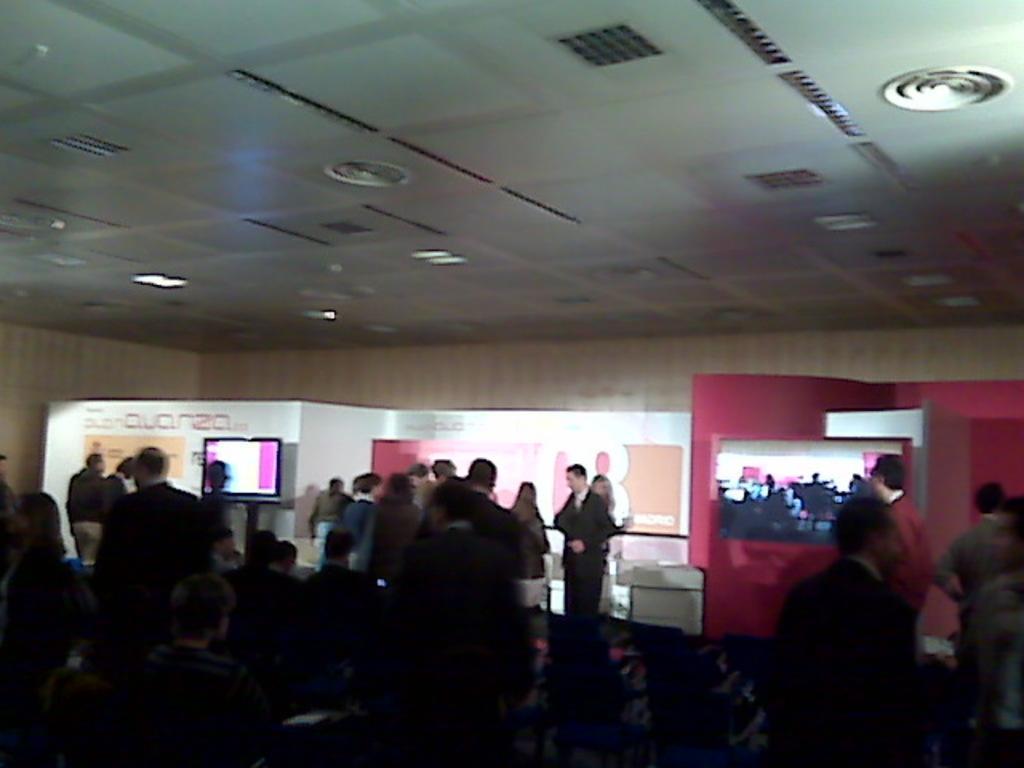Can you describe this image briefly? Here in this picture we can see group of people standing here and there on the floor over there and behind them we can see a banner present and we can also see a television present on a stand over there and on the roof we can see lights present over there. 